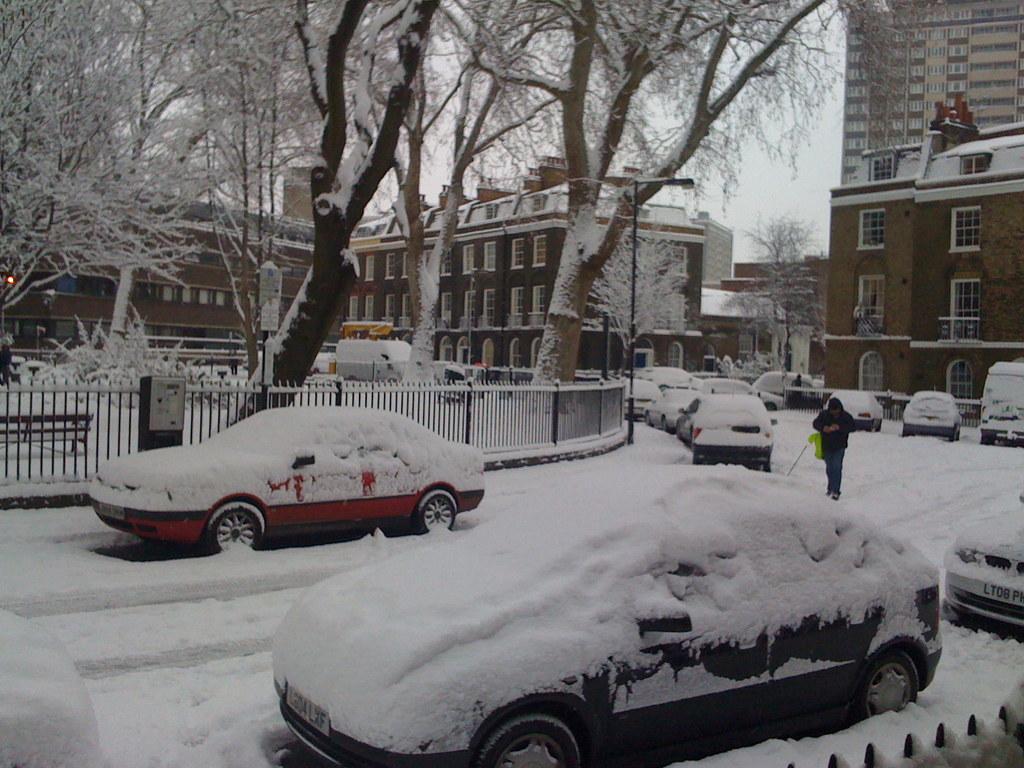Describe this image in one or two sentences. In this picture I can observe some cars parked on the road. There is some snow on the cars and on the land. I can observe a railing on the left side. In the background there are trees, buildings and sky. 